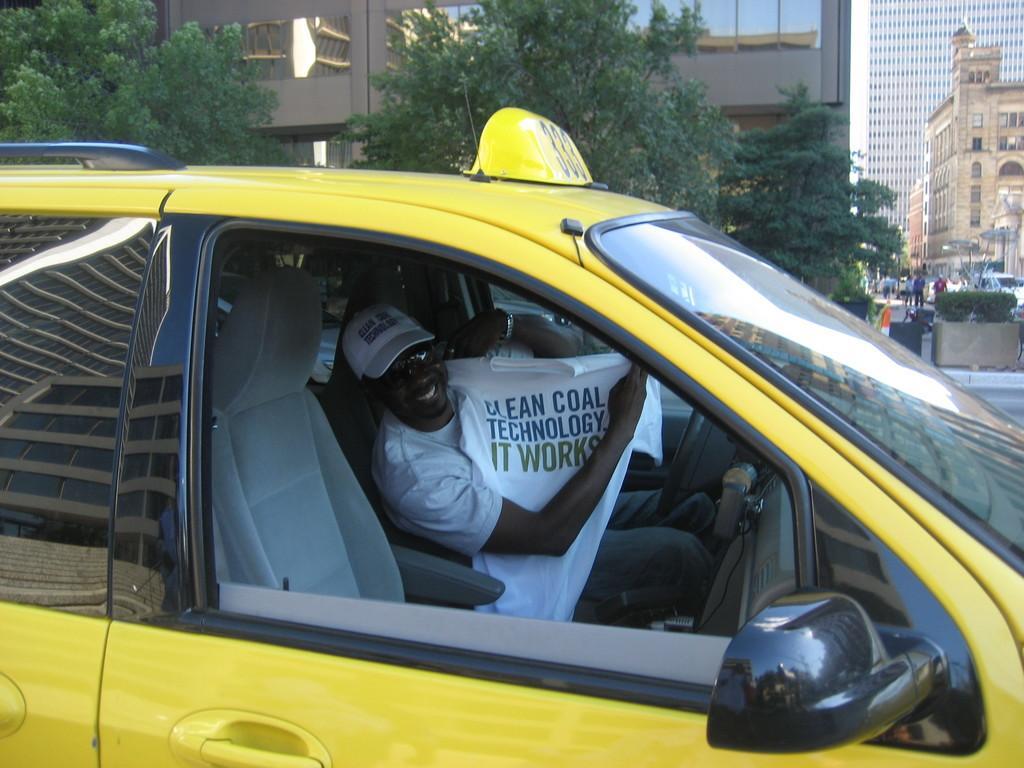Please provide a concise description of this image. In this picture there is a man in the center of the image in the car, by holding a t-shirt in his hands and there are buildings, trees, and other people in the background area of the image. 